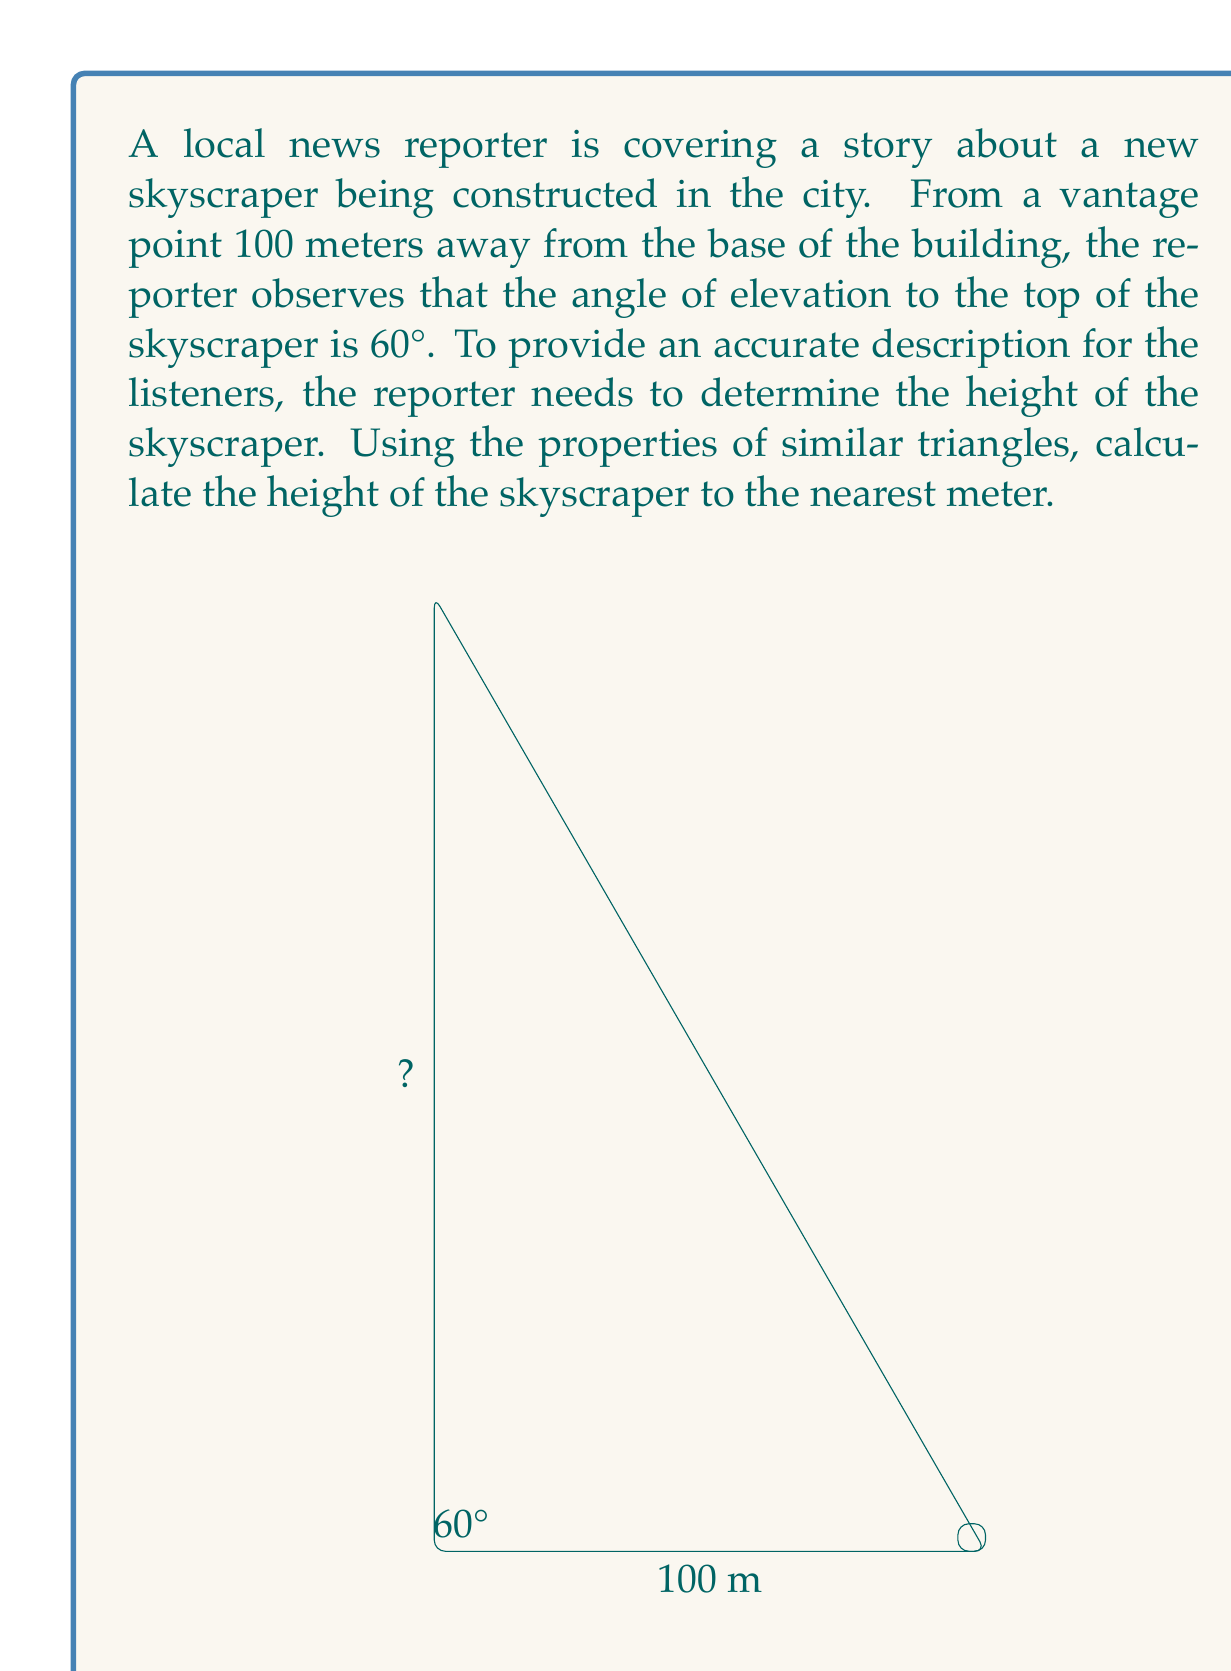Help me with this question. Let's approach this problem step-by-step using the properties of similar triangles:

1) First, we need to recognize that we have a right triangle. The ground forms the base, the skyscraper forms the height, and the line of sight from the reporter to the top of the skyscraper forms the hypotenuse.

2) We know that in a 30-60-90 triangle, the sides are in the ratio of 1 : $\sqrt{3}$ : 2.

3) In our case, the angle of elevation is 60°, so the adjacent side (distance from the reporter to the building) corresponds to the shorter leg of a 30-60-90 triangle.

4) Let's call the height of the skyscraper $h$. We can set up the following proportion:

   $$\frac{100}{\sqrt{3}} = \frac{h}{1}$$

5) Cross multiply:

   $$100 = h\sqrt{3}$$

6) Solve for $h$:

   $$h = \frac{100}{\sqrt{3}}$$

7) Simplify:

   $$h = 100 \cdot \frac{\sqrt{3}}{3} \approx 57.735$$

8) Rounding to the nearest meter:

   $$h \approx 58 \text{ meters}$$

Therefore, the height of the skyscraper is approximately 58 meters.
Answer: 58 meters 